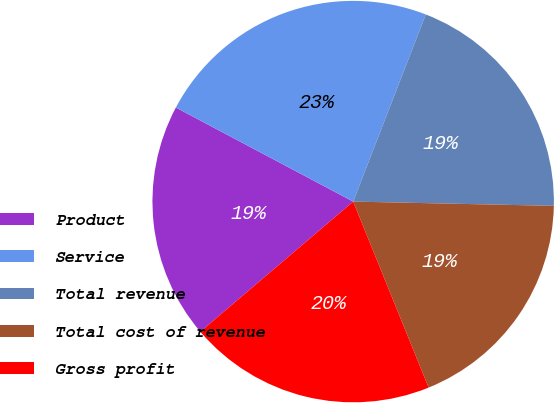Convert chart. <chart><loc_0><loc_0><loc_500><loc_500><pie_chart><fcel>Product<fcel>Service<fcel>Total revenue<fcel>Total cost of revenue<fcel>Gross profit<nl><fcel>18.99%<fcel>23.13%<fcel>19.45%<fcel>18.53%<fcel>19.91%<nl></chart> 